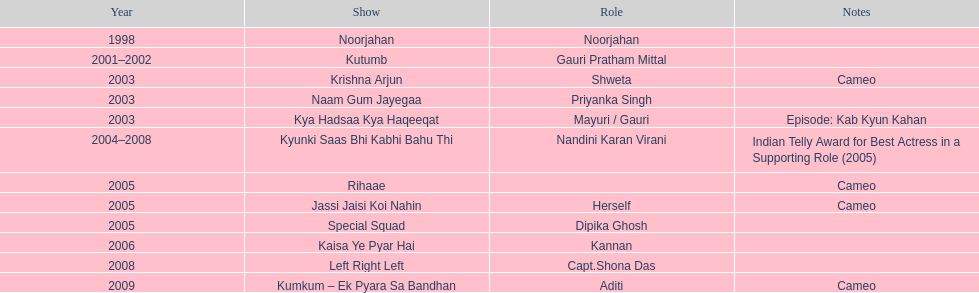What is the longest duration for which a show has lasted? 4. Parse the full table. {'header': ['Year', 'Show', 'Role', 'Notes'], 'rows': [['1998', 'Noorjahan', 'Noorjahan', ''], ['2001–2002', 'Kutumb', 'Gauri Pratham Mittal', ''], ['2003', 'Krishna Arjun', 'Shweta', 'Cameo'], ['2003', 'Naam Gum Jayegaa', 'Priyanka Singh', ''], ['2003', 'Kya Hadsaa Kya Haqeeqat', 'Mayuri / Gauri', 'Episode: Kab Kyun Kahan'], ['2004–2008', 'Kyunki Saas Bhi Kabhi Bahu Thi', 'Nandini Karan Virani', 'Indian Telly Award for Best Actress in a Supporting Role (2005)'], ['2005', 'Rihaae', '', 'Cameo'], ['2005', 'Jassi Jaisi Koi Nahin', 'Herself', 'Cameo'], ['2005', 'Special Squad', 'Dipika Ghosh', ''], ['2006', 'Kaisa Ye Pyar Hai', 'Kannan', ''], ['2008', 'Left Right Left', 'Capt.Shona Das', ''], ['2009', 'Kumkum – Ek Pyara Sa Bandhan', 'Aditi', 'Cameo']]} 